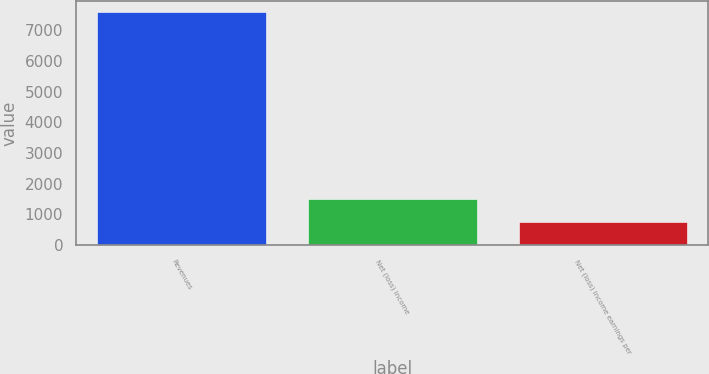Convert chart to OTSL. <chart><loc_0><loc_0><loc_500><loc_500><bar_chart><fcel>Revenues<fcel>Net (loss) income<fcel>Net (loss) income earnings per<nl><fcel>7582<fcel>1516.73<fcel>758.57<nl></chart> 